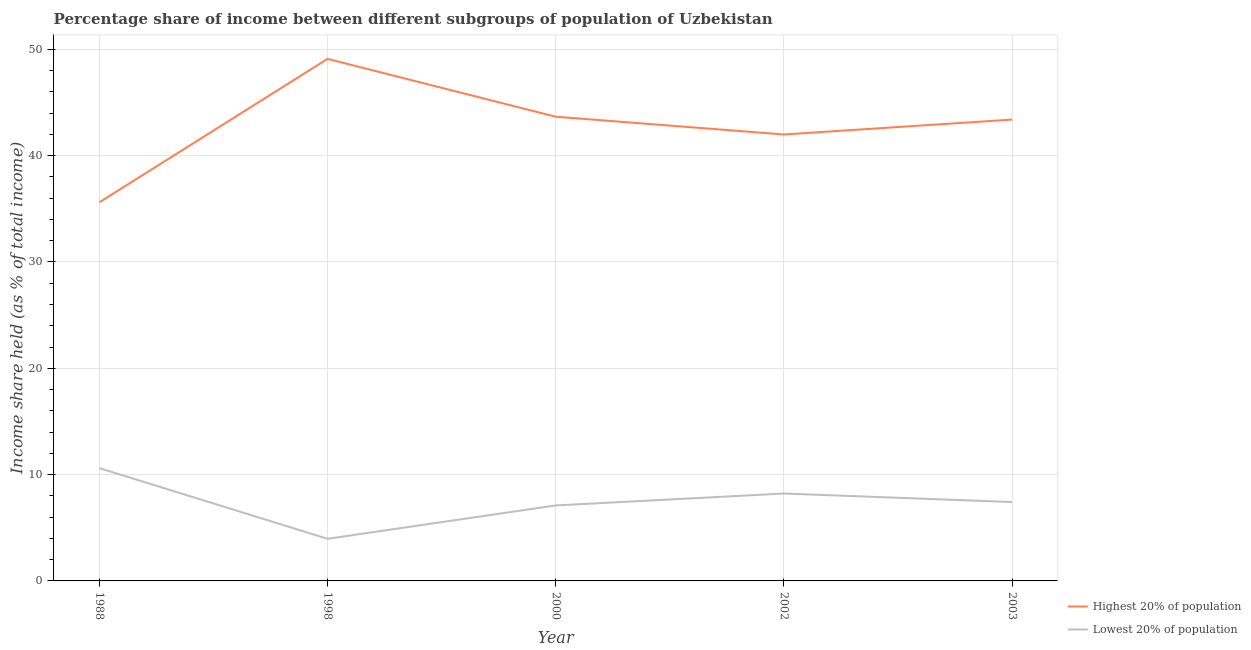Is the number of lines equal to the number of legend labels?
Your response must be concise. Yes. What is the income share held by highest 20% of the population in 2003?
Ensure brevity in your answer.  43.39. Across all years, what is the maximum income share held by lowest 20% of the population?
Offer a very short reply. 10.61. Across all years, what is the minimum income share held by lowest 20% of the population?
Keep it short and to the point. 3.96. In which year was the income share held by lowest 20% of the population maximum?
Give a very brief answer. 1988. What is the total income share held by highest 20% of the population in the graph?
Provide a succinct answer. 213.75. What is the difference between the income share held by highest 20% of the population in 1988 and that in 1998?
Make the answer very short. -13.49. What is the difference between the income share held by lowest 20% of the population in 1988 and the income share held by highest 20% of the population in 2000?
Offer a very short reply. -33.05. What is the average income share held by lowest 20% of the population per year?
Your answer should be compact. 7.46. In the year 1988, what is the difference between the income share held by highest 20% of the population and income share held by lowest 20% of the population?
Your answer should be compact. 25. What is the ratio of the income share held by highest 20% of the population in 1998 to that in 2002?
Offer a terse response. 1.17. Is the income share held by highest 20% of the population in 2000 less than that in 2003?
Offer a terse response. No. Is the difference between the income share held by highest 20% of the population in 1988 and 2003 greater than the difference between the income share held by lowest 20% of the population in 1988 and 2003?
Offer a terse response. No. What is the difference between the highest and the second highest income share held by highest 20% of the population?
Your answer should be compact. 5.44. What is the difference between the highest and the lowest income share held by lowest 20% of the population?
Offer a very short reply. 6.65. Does the income share held by highest 20% of the population monotonically increase over the years?
Offer a terse response. No. Is the income share held by highest 20% of the population strictly greater than the income share held by lowest 20% of the population over the years?
Offer a terse response. Yes. How many lines are there?
Offer a very short reply. 2. What is the difference between two consecutive major ticks on the Y-axis?
Your response must be concise. 10. Are the values on the major ticks of Y-axis written in scientific E-notation?
Ensure brevity in your answer.  No. Does the graph contain any zero values?
Your answer should be compact. No. Where does the legend appear in the graph?
Give a very brief answer. Bottom right. What is the title of the graph?
Offer a terse response. Percentage share of income between different subgroups of population of Uzbekistan. What is the label or title of the Y-axis?
Make the answer very short. Income share held (as % of total income). What is the Income share held (as % of total income) in Highest 20% of population in 1988?
Your answer should be compact. 35.61. What is the Income share held (as % of total income) of Lowest 20% of population in 1988?
Your answer should be very brief. 10.61. What is the Income share held (as % of total income) in Highest 20% of population in 1998?
Provide a short and direct response. 49.1. What is the Income share held (as % of total income) of Lowest 20% of population in 1998?
Provide a succinct answer. 3.96. What is the Income share held (as % of total income) in Highest 20% of population in 2000?
Offer a very short reply. 43.66. What is the Income share held (as % of total income) of Highest 20% of population in 2002?
Make the answer very short. 41.99. What is the Income share held (as % of total income) of Lowest 20% of population in 2002?
Provide a succinct answer. 8.22. What is the Income share held (as % of total income) in Highest 20% of population in 2003?
Your response must be concise. 43.39. What is the Income share held (as % of total income) in Lowest 20% of population in 2003?
Make the answer very short. 7.42. Across all years, what is the maximum Income share held (as % of total income) of Highest 20% of population?
Give a very brief answer. 49.1. Across all years, what is the maximum Income share held (as % of total income) of Lowest 20% of population?
Keep it short and to the point. 10.61. Across all years, what is the minimum Income share held (as % of total income) in Highest 20% of population?
Your response must be concise. 35.61. Across all years, what is the minimum Income share held (as % of total income) of Lowest 20% of population?
Your answer should be very brief. 3.96. What is the total Income share held (as % of total income) of Highest 20% of population in the graph?
Provide a short and direct response. 213.75. What is the total Income share held (as % of total income) in Lowest 20% of population in the graph?
Your response must be concise. 37.31. What is the difference between the Income share held (as % of total income) in Highest 20% of population in 1988 and that in 1998?
Your answer should be compact. -13.49. What is the difference between the Income share held (as % of total income) of Lowest 20% of population in 1988 and that in 1998?
Your response must be concise. 6.65. What is the difference between the Income share held (as % of total income) in Highest 20% of population in 1988 and that in 2000?
Keep it short and to the point. -8.05. What is the difference between the Income share held (as % of total income) of Lowest 20% of population in 1988 and that in 2000?
Your answer should be very brief. 3.51. What is the difference between the Income share held (as % of total income) of Highest 20% of population in 1988 and that in 2002?
Make the answer very short. -6.38. What is the difference between the Income share held (as % of total income) in Lowest 20% of population in 1988 and that in 2002?
Keep it short and to the point. 2.39. What is the difference between the Income share held (as % of total income) of Highest 20% of population in 1988 and that in 2003?
Offer a very short reply. -7.78. What is the difference between the Income share held (as % of total income) in Lowest 20% of population in 1988 and that in 2003?
Keep it short and to the point. 3.19. What is the difference between the Income share held (as % of total income) of Highest 20% of population in 1998 and that in 2000?
Keep it short and to the point. 5.44. What is the difference between the Income share held (as % of total income) of Lowest 20% of population in 1998 and that in 2000?
Your answer should be compact. -3.14. What is the difference between the Income share held (as % of total income) of Highest 20% of population in 1998 and that in 2002?
Provide a short and direct response. 7.11. What is the difference between the Income share held (as % of total income) of Lowest 20% of population in 1998 and that in 2002?
Your answer should be very brief. -4.26. What is the difference between the Income share held (as % of total income) of Highest 20% of population in 1998 and that in 2003?
Ensure brevity in your answer.  5.71. What is the difference between the Income share held (as % of total income) in Lowest 20% of population in 1998 and that in 2003?
Keep it short and to the point. -3.46. What is the difference between the Income share held (as % of total income) of Highest 20% of population in 2000 and that in 2002?
Offer a terse response. 1.67. What is the difference between the Income share held (as % of total income) in Lowest 20% of population in 2000 and that in 2002?
Offer a terse response. -1.12. What is the difference between the Income share held (as % of total income) of Highest 20% of population in 2000 and that in 2003?
Your response must be concise. 0.27. What is the difference between the Income share held (as % of total income) in Lowest 20% of population in 2000 and that in 2003?
Provide a succinct answer. -0.32. What is the difference between the Income share held (as % of total income) in Lowest 20% of population in 2002 and that in 2003?
Your response must be concise. 0.8. What is the difference between the Income share held (as % of total income) in Highest 20% of population in 1988 and the Income share held (as % of total income) in Lowest 20% of population in 1998?
Provide a short and direct response. 31.65. What is the difference between the Income share held (as % of total income) in Highest 20% of population in 1988 and the Income share held (as % of total income) in Lowest 20% of population in 2000?
Provide a short and direct response. 28.51. What is the difference between the Income share held (as % of total income) in Highest 20% of population in 1988 and the Income share held (as % of total income) in Lowest 20% of population in 2002?
Provide a succinct answer. 27.39. What is the difference between the Income share held (as % of total income) in Highest 20% of population in 1988 and the Income share held (as % of total income) in Lowest 20% of population in 2003?
Provide a short and direct response. 28.19. What is the difference between the Income share held (as % of total income) in Highest 20% of population in 1998 and the Income share held (as % of total income) in Lowest 20% of population in 2000?
Give a very brief answer. 42. What is the difference between the Income share held (as % of total income) in Highest 20% of population in 1998 and the Income share held (as % of total income) in Lowest 20% of population in 2002?
Offer a terse response. 40.88. What is the difference between the Income share held (as % of total income) of Highest 20% of population in 1998 and the Income share held (as % of total income) of Lowest 20% of population in 2003?
Offer a terse response. 41.68. What is the difference between the Income share held (as % of total income) of Highest 20% of population in 2000 and the Income share held (as % of total income) of Lowest 20% of population in 2002?
Make the answer very short. 35.44. What is the difference between the Income share held (as % of total income) of Highest 20% of population in 2000 and the Income share held (as % of total income) of Lowest 20% of population in 2003?
Ensure brevity in your answer.  36.24. What is the difference between the Income share held (as % of total income) in Highest 20% of population in 2002 and the Income share held (as % of total income) in Lowest 20% of population in 2003?
Your answer should be compact. 34.57. What is the average Income share held (as % of total income) in Highest 20% of population per year?
Ensure brevity in your answer.  42.75. What is the average Income share held (as % of total income) in Lowest 20% of population per year?
Provide a short and direct response. 7.46. In the year 1988, what is the difference between the Income share held (as % of total income) in Highest 20% of population and Income share held (as % of total income) in Lowest 20% of population?
Offer a very short reply. 25. In the year 1998, what is the difference between the Income share held (as % of total income) in Highest 20% of population and Income share held (as % of total income) in Lowest 20% of population?
Provide a short and direct response. 45.14. In the year 2000, what is the difference between the Income share held (as % of total income) in Highest 20% of population and Income share held (as % of total income) in Lowest 20% of population?
Keep it short and to the point. 36.56. In the year 2002, what is the difference between the Income share held (as % of total income) in Highest 20% of population and Income share held (as % of total income) in Lowest 20% of population?
Make the answer very short. 33.77. In the year 2003, what is the difference between the Income share held (as % of total income) of Highest 20% of population and Income share held (as % of total income) of Lowest 20% of population?
Ensure brevity in your answer.  35.97. What is the ratio of the Income share held (as % of total income) in Highest 20% of population in 1988 to that in 1998?
Keep it short and to the point. 0.73. What is the ratio of the Income share held (as % of total income) of Lowest 20% of population in 1988 to that in 1998?
Provide a short and direct response. 2.68. What is the ratio of the Income share held (as % of total income) of Highest 20% of population in 1988 to that in 2000?
Provide a succinct answer. 0.82. What is the ratio of the Income share held (as % of total income) in Lowest 20% of population in 1988 to that in 2000?
Your response must be concise. 1.49. What is the ratio of the Income share held (as % of total income) of Highest 20% of population in 1988 to that in 2002?
Offer a terse response. 0.85. What is the ratio of the Income share held (as % of total income) of Lowest 20% of population in 1988 to that in 2002?
Offer a terse response. 1.29. What is the ratio of the Income share held (as % of total income) of Highest 20% of population in 1988 to that in 2003?
Give a very brief answer. 0.82. What is the ratio of the Income share held (as % of total income) in Lowest 20% of population in 1988 to that in 2003?
Offer a terse response. 1.43. What is the ratio of the Income share held (as % of total income) of Highest 20% of population in 1998 to that in 2000?
Your answer should be compact. 1.12. What is the ratio of the Income share held (as % of total income) of Lowest 20% of population in 1998 to that in 2000?
Your answer should be compact. 0.56. What is the ratio of the Income share held (as % of total income) in Highest 20% of population in 1998 to that in 2002?
Your answer should be very brief. 1.17. What is the ratio of the Income share held (as % of total income) in Lowest 20% of population in 1998 to that in 2002?
Ensure brevity in your answer.  0.48. What is the ratio of the Income share held (as % of total income) of Highest 20% of population in 1998 to that in 2003?
Your response must be concise. 1.13. What is the ratio of the Income share held (as % of total income) of Lowest 20% of population in 1998 to that in 2003?
Provide a succinct answer. 0.53. What is the ratio of the Income share held (as % of total income) in Highest 20% of population in 2000 to that in 2002?
Make the answer very short. 1.04. What is the ratio of the Income share held (as % of total income) in Lowest 20% of population in 2000 to that in 2002?
Ensure brevity in your answer.  0.86. What is the ratio of the Income share held (as % of total income) of Highest 20% of population in 2000 to that in 2003?
Keep it short and to the point. 1.01. What is the ratio of the Income share held (as % of total income) of Lowest 20% of population in 2000 to that in 2003?
Provide a succinct answer. 0.96. What is the ratio of the Income share held (as % of total income) of Lowest 20% of population in 2002 to that in 2003?
Ensure brevity in your answer.  1.11. What is the difference between the highest and the second highest Income share held (as % of total income) of Highest 20% of population?
Your response must be concise. 5.44. What is the difference between the highest and the second highest Income share held (as % of total income) of Lowest 20% of population?
Ensure brevity in your answer.  2.39. What is the difference between the highest and the lowest Income share held (as % of total income) of Highest 20% of population?
Your answer should be very brief. 13.49. What is the difference between the highest and the lowest Income share held (as % of total income) in Lowest 20% of population?
Offer a terse response. 6.65. 